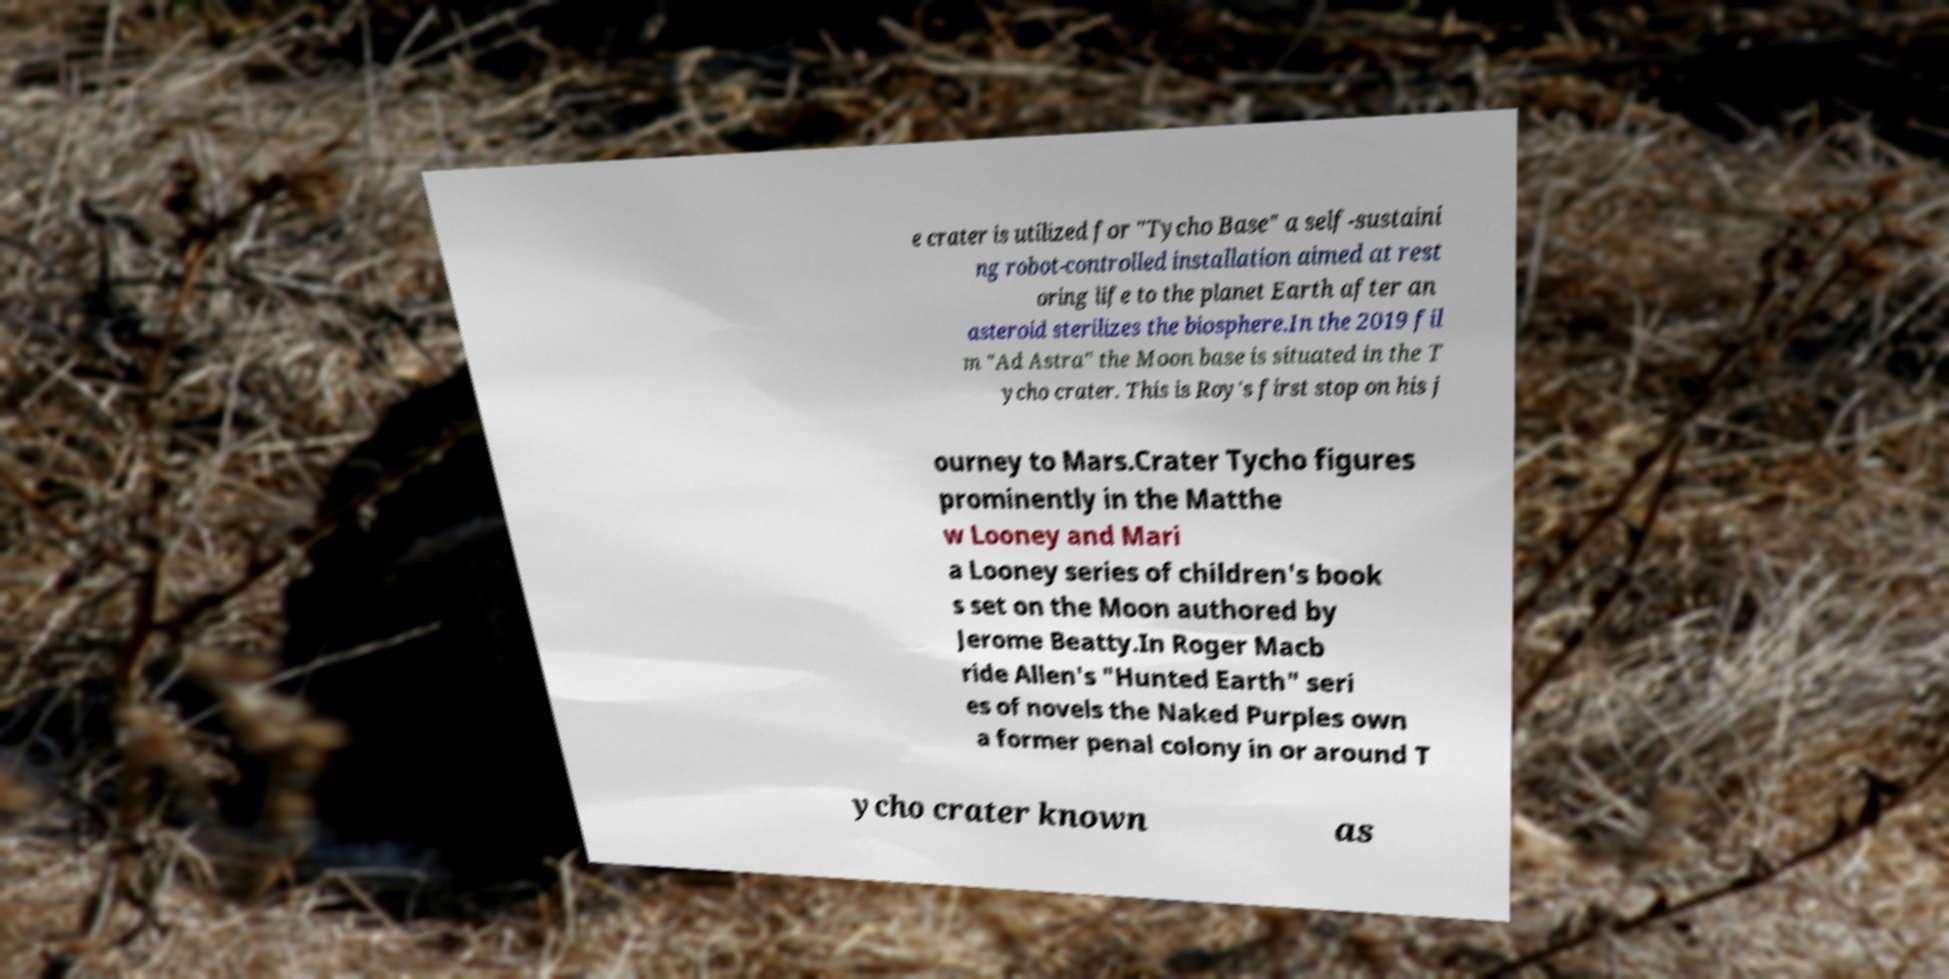Could you assist in decoding the text presented in this image and type it out clearly? e crater is utilized for "Tycho Base" a self-sustaini ng robot-controlled installation aimed at rest oring life to the planet Earth after an asteroid sterilizes the biosphere.In the 2019 fil m "Ad Astra" the Moon base is situated in the T ycho crater. This is Roy's first stop on his j ourney to Mars.Crater Tycho figures prominently in the Matthe w Looney and Mari a Looney series of children's book s set on the Moon authored by Jerome Beatty.In Roger Macb ride Allen's "Hunted Earth" seri es of novels the Naked Purples own a former penal colony in or around T ycho crater known as 